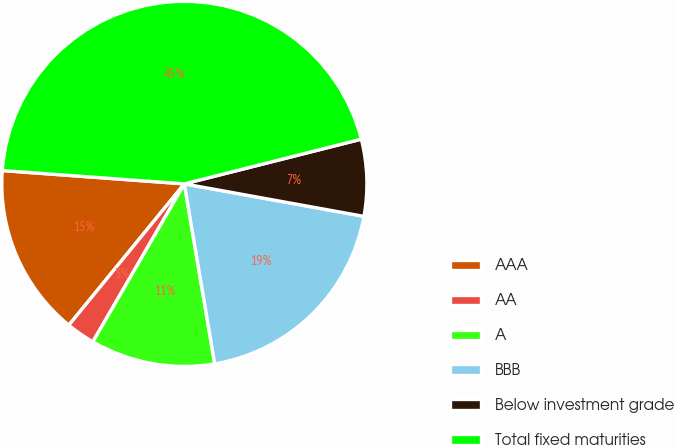<chart> <loc_0><loc_0><loc_500><loc_500><pie_chart><fcel>AAA<fcel>AA<fcel>A<fcel>BBB<fcel>Below investment grade<fcel>Total fixed maturities<nl><fcel>15.26%<fcel>2.55%<fcel>11.02%<fcel>19.49%<fcel>6.79%<fcel>44.9%<nl></chart> 